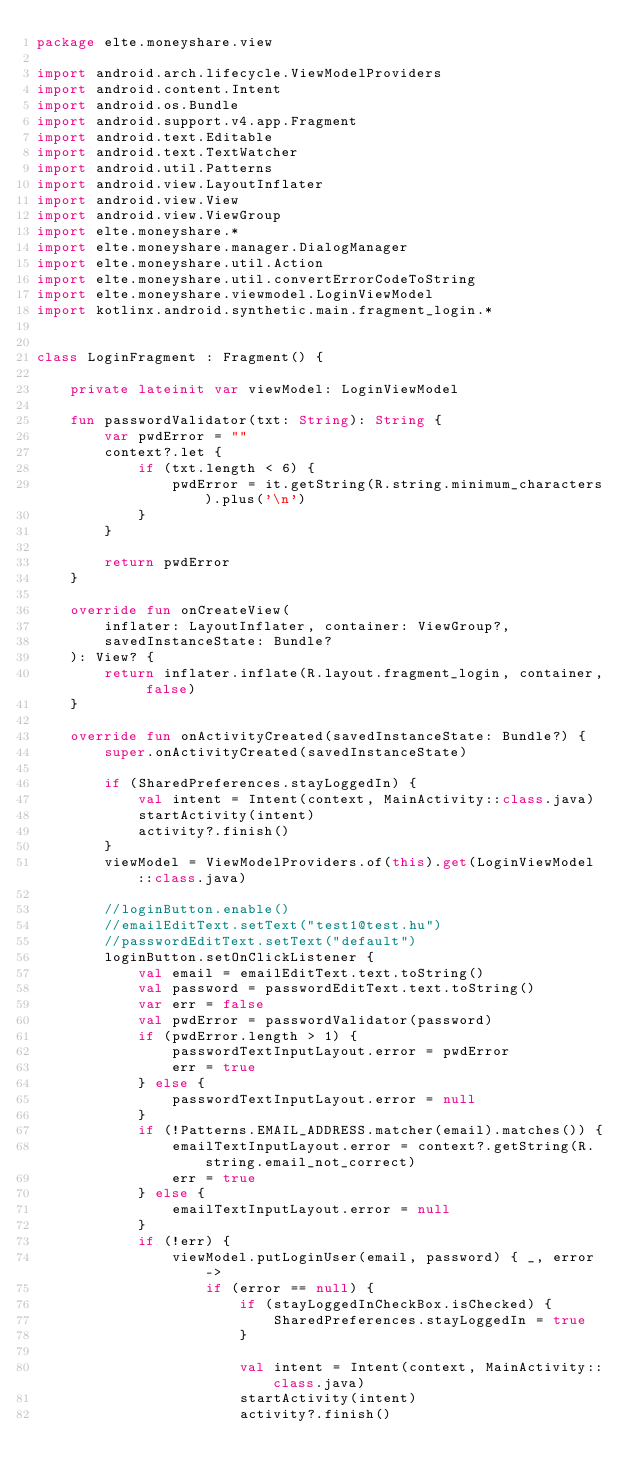Convert code to text. <code><loc_0><loc_0><loc_500><loc_500><_Kotlin_>package elte.moneyshare.view

import android.arch.lifecycle.ViewModelProviders
import android.content.Intent
import android.os.Bundle
import android.support.v4.app.Fragment
import android.text.Editable
import android.text.TextWatcher
import android.util.Patterns
import android.view.LayoutInflater
import android.view.View
import android.view.ViewGroup
import elte.moneyshare.*
import elte.moneyshare.manager.DialogManager
import elte.moneyshare.util.Action
import elte.moneyshare.util.convertErrorCodeToString
import elte.moneyshare.viewmodel.LoginViewModel
import kotlinx.android.synthetic.main.fragment_login.*


class LoginFragment : Fragment() {

    private lateinit var viewModel: LoginViewModel

    fun passwordValidator(txt: String): String {
        var pwdError = ""
        context?.let {
            if (txt.length < 6) {
                pwdError = it.getString(R.string.minimum_characters).plus('\n')
            }
        }

        return pwdError
    }

    override fun onCreateView(
        inflater: LayoutInflater, container: ViewGroup?,
        savedInstanceState: Bundle?
    ): View? {
        return inflater.inflate(R.layout.fragment_login, container, false)
    }

    override fun onActivityCreated(savedInstanceState: Bundle?) {
        super.onActivityCreated(savedInstanceState)

        if (SharedPreferences.stayLoggedIn) {
            val intent = Intent(context, MainActivity::class.java)
            startActivity(intent)
            activity?.finish()
        }
        viewModel = ViewModelProviders.of(this).get(LoginViewModel::class.java)

        //loginButton.enable()
        //emailEditText.setText("test1@test.hu")
        //passwordEditText.setText("default")
        loginButton.setOnClickListener {
            val email = emailEditText.text.toString()
            val password = passwordEditText.text.toString()
            var err = false
            val pwdError = passwordValidator(password)
            if (pwdError.length > 1) {
                passwordTextInputLayout.error = pwdError
                err = true
            } else {
                passwordTextInputLayout.error = null
            }
            if (!Patterns.EMAIL_ADDRESS.matcher(email).matches()) {
                emailTextInputLayout.error = context?.getString(R.string.email_not_correct)
                err = true
            } else {
                emailTextInputLayout.error = null
            }
            if (!err) {
                viewModel.putLoginUser(email, password) { _, error ->
                    if (error == null) {
                        if (stayLoggedInCheckBox.isChecked) {
                            SharedPreferences.stayLoggedIn = true
                        }

                        val intent = Intent(context, MainActivity::class.java)
                        startActivity(intent)
                        activity?.finish()</code> 